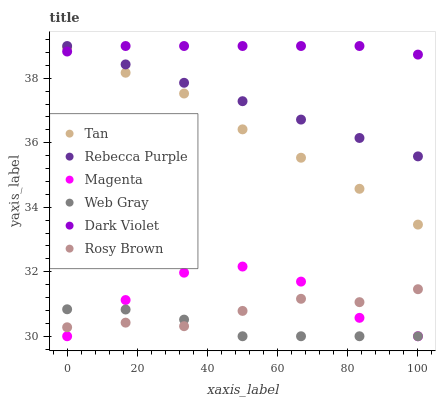Does Web Gray have the minimum area under the curve?
Answer yes or no. Yes. Does Dark Violet have the maximum area under the curve?
Answer yes or no. Yes. Does Rosy Brown have the minimum area under the curve?
Answer yes or no. No. Does Rosy Brown have the maximum area under the curve?
Answer yes or no. No. Is Rebecca Purple the smoothest?
Answer yes or no. Yes. Is Magenta the roughest?
Answer yes or no. Yes. Is Rosy Brown the smoothest?
Answer yes or no. No. Is Rosy Brown the roughest?
Answer yes or no. No. Does Web Gray have the lowest value?
Answer yes or no. Yes. Does Rosy Brown have the lowest value?
Answer yes or no. No. Does Rebecca Purple have the highest value?
Answer yes or no. Yes. Does Rosy Brown have the highest value?
Answer yes or no. No. Is Web Gray less than Tan?
Answer yes or no. Yes. Is Rebecca Purple greater than Rosy Brown?
Answer yes or no. Yes. Does Dark Violet intersect Rebecca Purple?
Answer yes or no. Yes. Is Dark Violet less than Rebecca Purple?
Answer yes or no. No. Is Dark Violet greater than Rebecca Purple?
Answer yes or no. No. Does Web Gray intersect Tan?
Answer yes or no. No. 